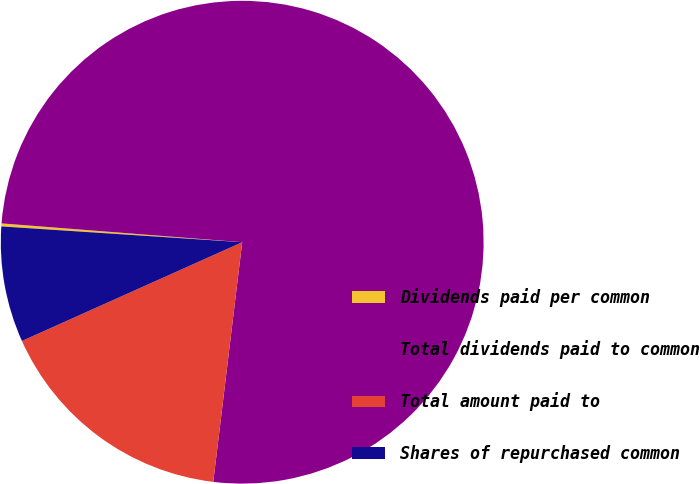Convert chart. <chart><loc_0><loc_0><loc_500><loc_500><pie_chart><fcel>Dividends paid per common<fcel>Total dividends paid to common<fcel>Total amount paid to<fcel>Shares of repurchased common<nl><fcel>0.2%<fcel>75.67%<fcel>16.38%<fcel>7.75%<nl></chart> 